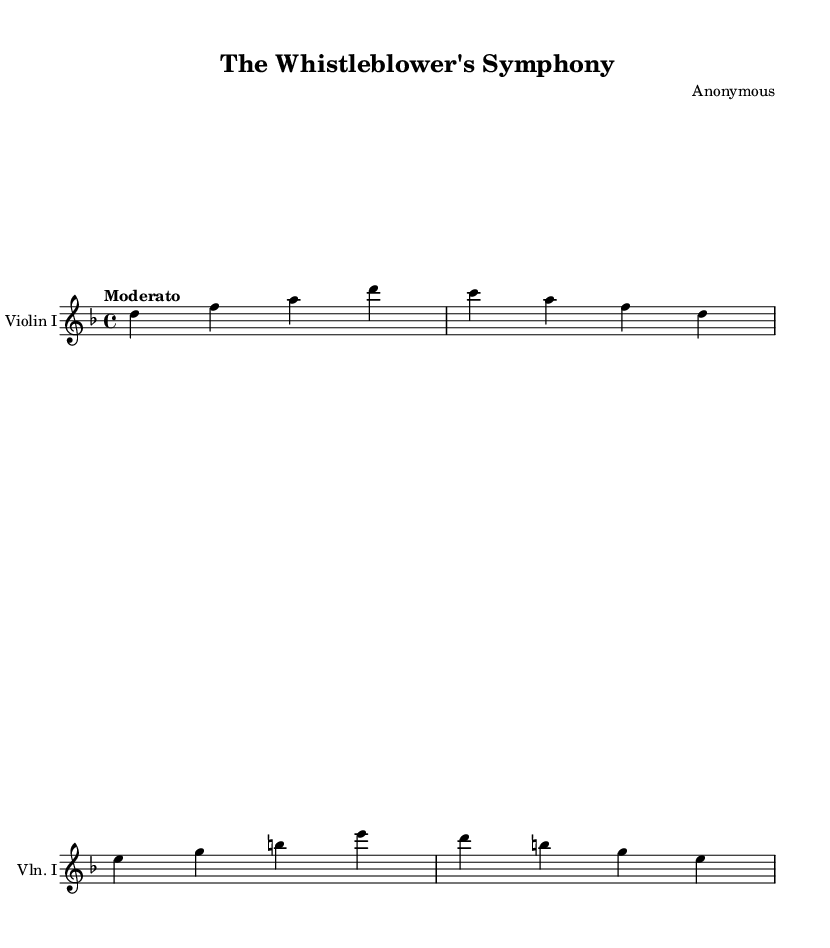What is the key signature of this music? The key signature is D minor, which has one flat (B flat). This can be identified by looking to the beginning of the staff where the key signature is indicated.
Answer: D minor What is the time signature of this music? The time signature is indicated at the beginning of the staff as 4/4, meaning there are four beats per measure and a quarter note gets one beat.
Answer: 4/4 What is the tempo indication of this piece? The tempo is defined as "Moderato," which suggests a moderately paced tempo. This information is provided in the score just below the staff at the start.
Answer: Moderato How many measures are present in the provided excerpt? The excerpt contains four measures, which can be counted by looking at the vertical bar lines separating each measure.
Answer: 4 What is the highest note played in the score? The highest note is D, located in the first measure as the first note of the line. By visually inspecting the notes in the staff, D is identified as the peak pitch.
Answer: D What is the lowest note played in the score? The lowest note is A, which can be found in the second measure as the third note. Observing the notes and their positions on the staff reveals A as the lowest pitch.
Answer: A 